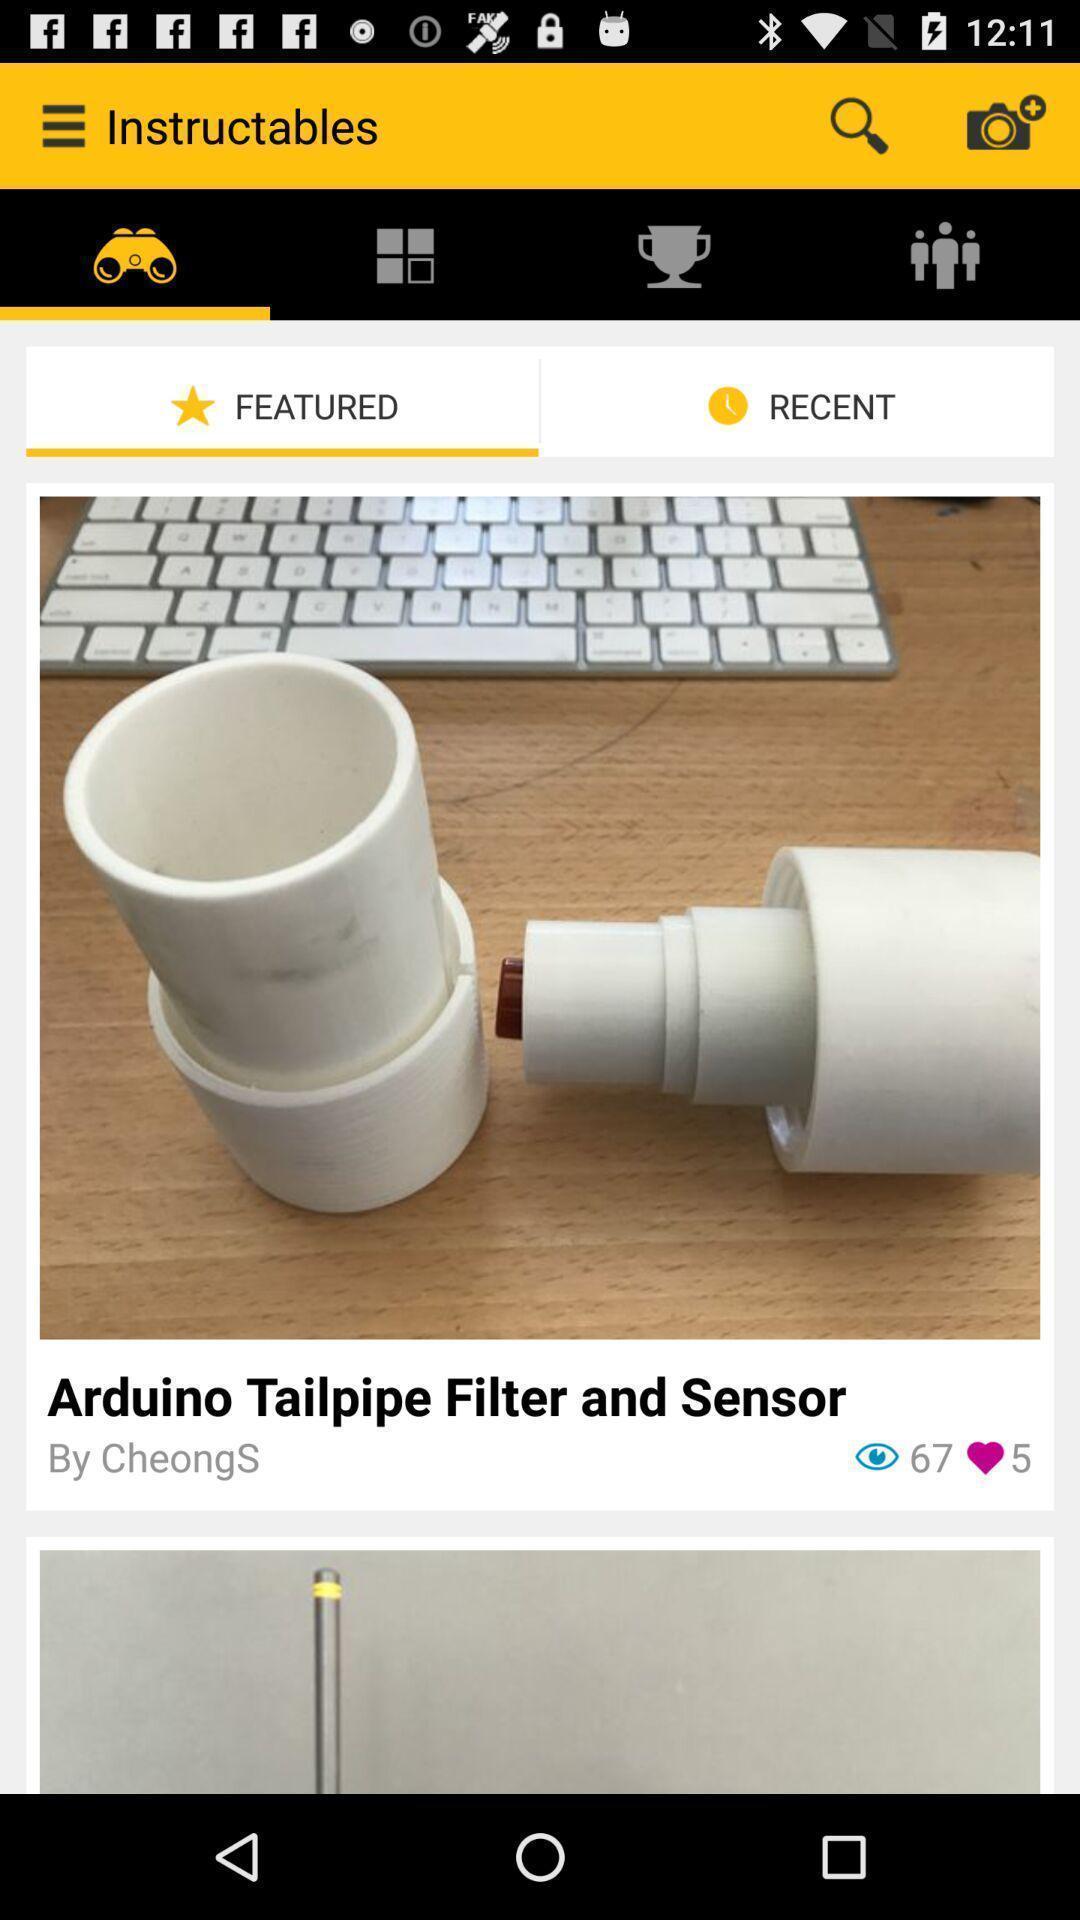Give me a narrative description of this picture. Social app showing featuring news. 